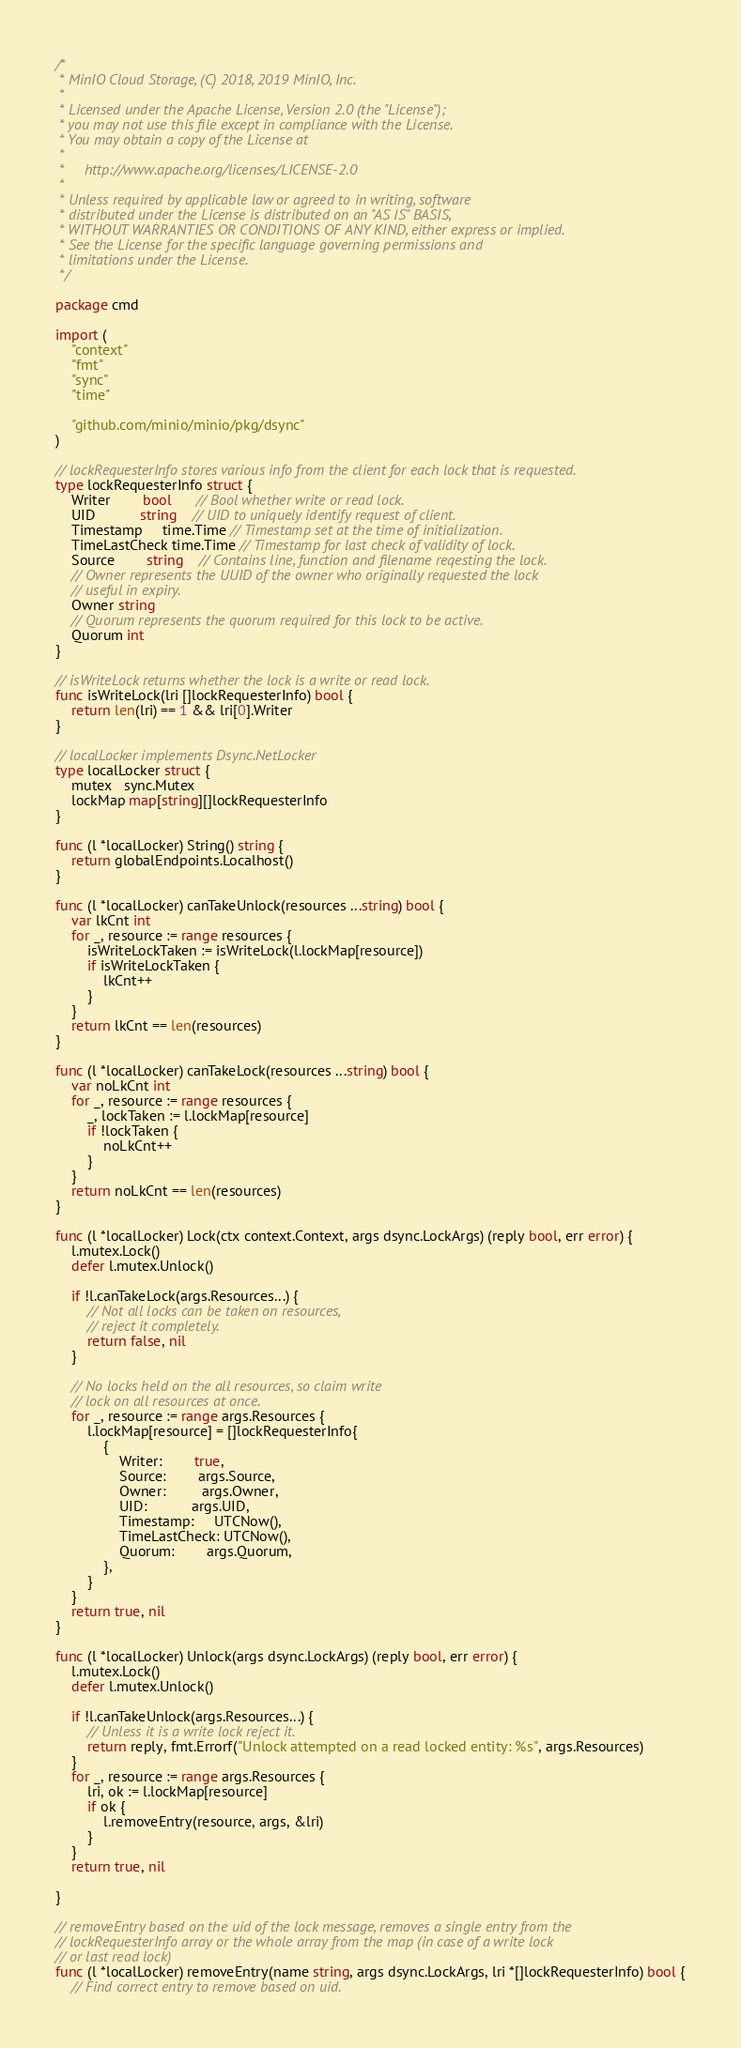Convert code to text. <code><loc_0><loc_0><loc_500><loc_500><_Go_>/*
 * MinIO Cloud Storage, (C) 2018, 2019 MinIO, Inc.
 *
 * Licensed under the Apache License, Version 2.0 (the "License");
 * you may not use this file except in compliance with the License.
 * You may obtain a copy of the License at
 *
 *     http://www.apache.org/licenses/LICENSE-2.0
 *
 * Unless required by applicable law or agreed to in writing, software
 * distributed under the License is distributed on an "AS IS" BASIS,
 * WITHOUT WARRANTIES OR CONDITIONS OF ANY KIND, either express or implied.
 * See the License for the specific language governing permissions and
 * limitations under the License.
 */

package cmd

import (
	"context"
	"fmt"
	"sync"
	"time"

	"github.com/minio/minio/pkg/dsync"
)

// lockRequesterInfo stores various info from the client for each lock that is requested.
type lockRequesterInfo struct {
	Writer        bool      // Bool whether write or read lock.
	UID           string    // UID to uniquely identify request of client.
	Timestamp     time.Time // Timestamp set at the time of initialization.
	TimeLastCheck time.Time // Timestamp for last check of validity of lock.
	Source        string    // Contains line, function and filename reqesting the lock.
	// Owner represents the UUID of the owner who originally requested the lock
	// useful in expiry.
	Owner string
	// Quorum represents the quorum required for this lock to be active.
	Quorum int
}

// isWriteLock returns whether the lock is a write or read lock.
func isWriteLock(lri []lockRequesterInfo) bool {
	return len(lri) == 1 && lri[0].Writer
}

// localLocker implements Dsync.NetLocker
type localLocker struct {
	mutex   sync.Mutex
	lockMap map[string][]lockRequesterInfo
}

func (l *localLocker) String() string {
	return globalEndpoints.Localhost()
}

func (l *localLocker) canTakeUnlock(resources ...string) bool {
	var lkCnt int
	for _, resource := range resources {
		isWriteLockTaken := isWriteLock(l.lockMap[resource])
		if isWriteLockTaken {
			lkCnt++
		}
	}
	return lkCnt == len(resources)
}

func (l *localLocker) canTakeLock(resources ...string) bool {
	var noLkCnt int
	for _, resource := range resources {
		_, lockTaken := l.lockMap[resource]
		if !lockTaken {
			noLkCnt++
		}
	}
	return noLkCnt == len(resources)
}

func (l *localLocker) Lock(ctx context.Context, args dsync.LockArgs) (reply bool, err error) {
	l.mutex.Lock()
	defer l.mutex.Unlock()

	if !l.canTakeLock(args.Resources...) {
		// Not all locks can be taken on resources,
		// reject it completely.
		return false, nil
	}

	// No locks held on the all resources, so claim write
	// lock on all resources at once.
	for _, resource := range args.Resources {
		l.lockMap[resource] = []lockRequesterInfo{
			{
				Writer:        true,
				Source:        args.Source,
				Owner:         args.Owner,
				UID:           args.UID,
				Timestamp:     UTCNow(),
				TimeLastCheck: UTCNow(),
				Quorum:        args.Quorum,
			},
		}
	}
	return true, nil
}

func (l *localLocker) Unlock(args dsync.LockArgs) (reply bool, err error) {
	l.mutex.Lock()
	defer l.mutex.Unlock()

	if !l.canTakeUnlock(args.Resources...) {
		// Unless it is a write lock reject it.
		return reply, fmt.Errorf("Unlock attempted on a read locked entity: %s", args.Resources)
	}
	for _, resource := range args.Resources {
		lri, ok := l.lockMap[resource]
		if ok {
			l.removeEntry(resource, args, &lri)
		}
	}
	return true, nil

}

// removeEntry based on the uid of the lock message, removes a single entry from the
// lockRequesterInfo array or the whole array from the map (in case of a write lock
// or last read lock)
func (l *localLocker) removeEntry(name string, args dsync.LockArgs, lri *[]lockRequesterInfo) bool {
	// Find correct entry to remove based on uid.</code> 